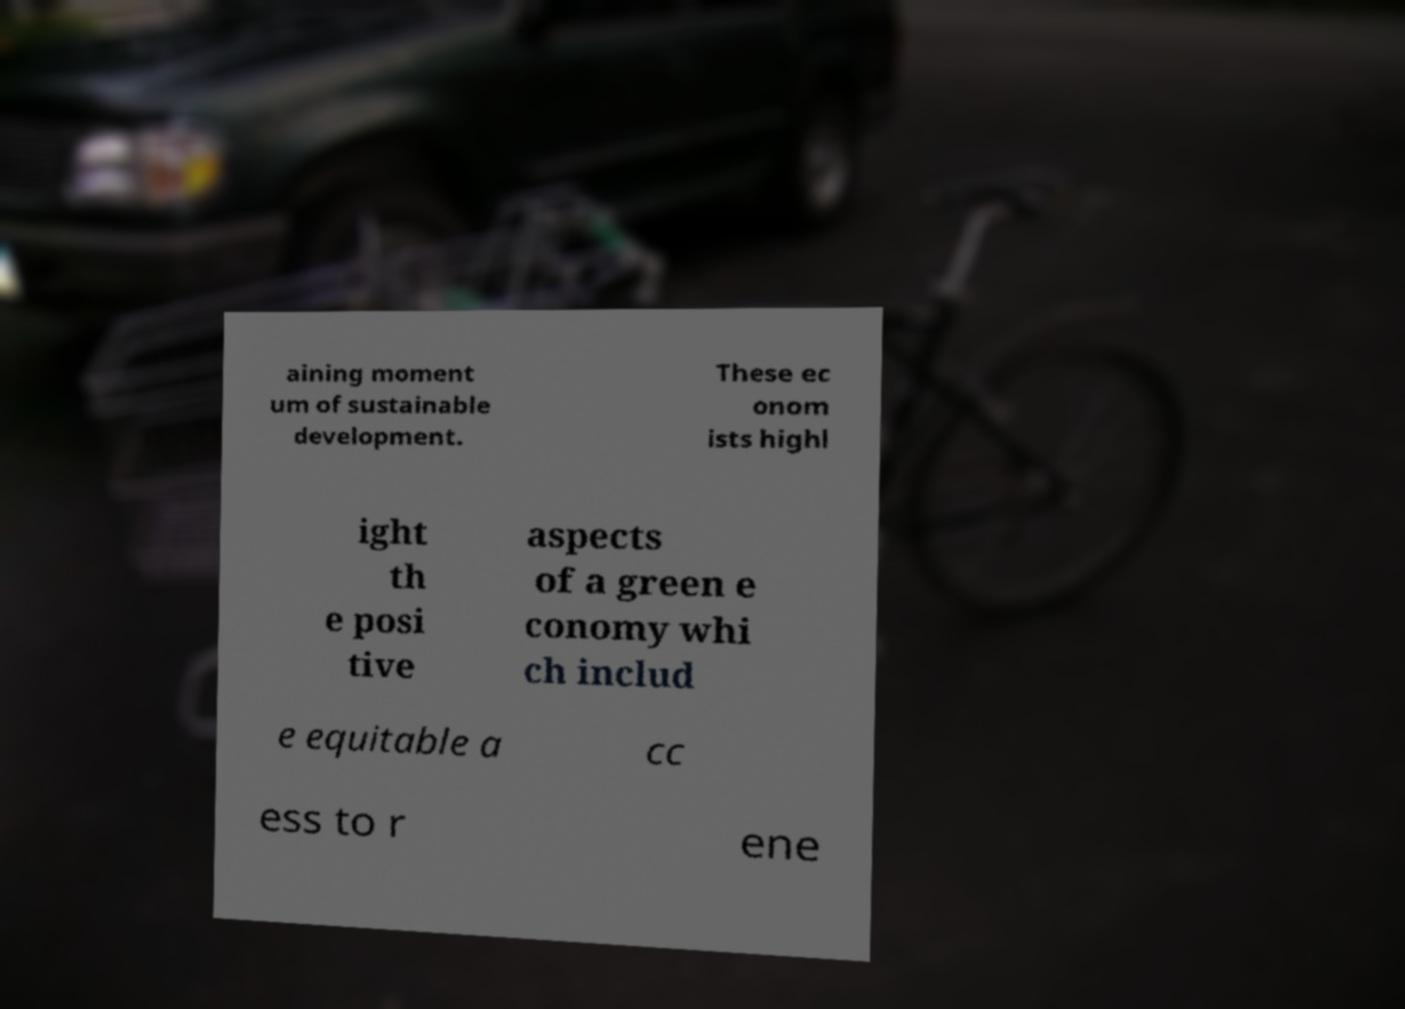Can you read and provide the text displayed in the image?This photo seems to have some interesting text. Can you extract and type it out for me? aining moment um of sustainable development. These ec onom ists highl ight th e posi tive aspects of a green e conomy whi ch includ e equitable a cc ess to r ene 